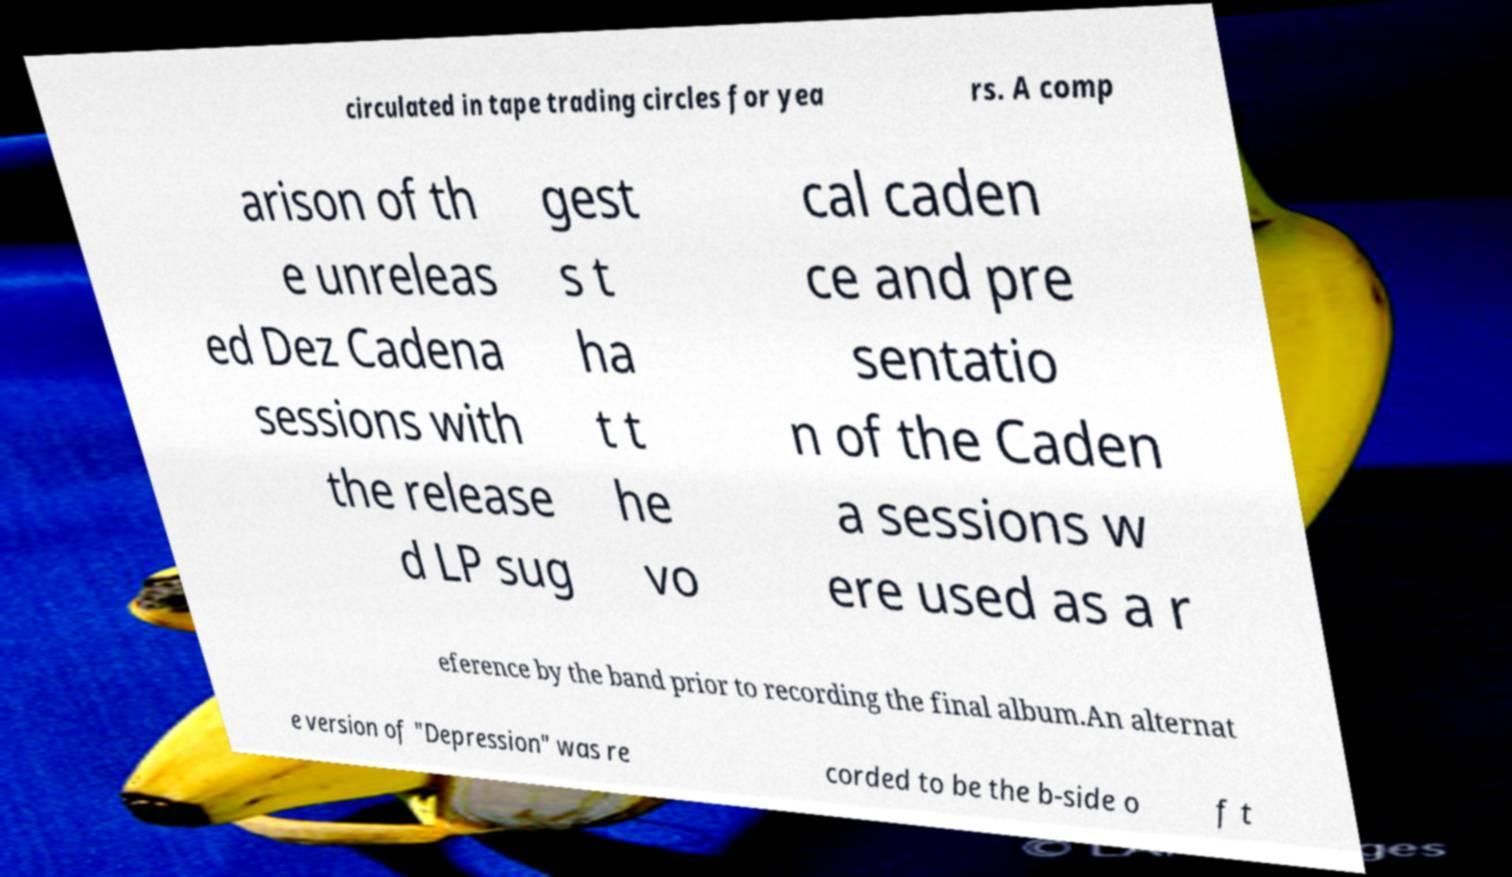For documentation purposes, I need the text within this image transcribed. Could you provide that? circulated in tape trading circles for yea rs. A comp arison of th e unreleas ed Dez Cadena sessions with the release d LP sug gest s t ha t t he vo cal caden ce and pre sentatio n of the Caden a sessions w ere used as a r eference by the band prior to recording the final album.An alternat e version of "Depression" was re corded to be the b-side o f t 